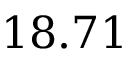<formula> <loc_0><loc_0><loc_500><loc_500>1 8 . 7 1</formula> 